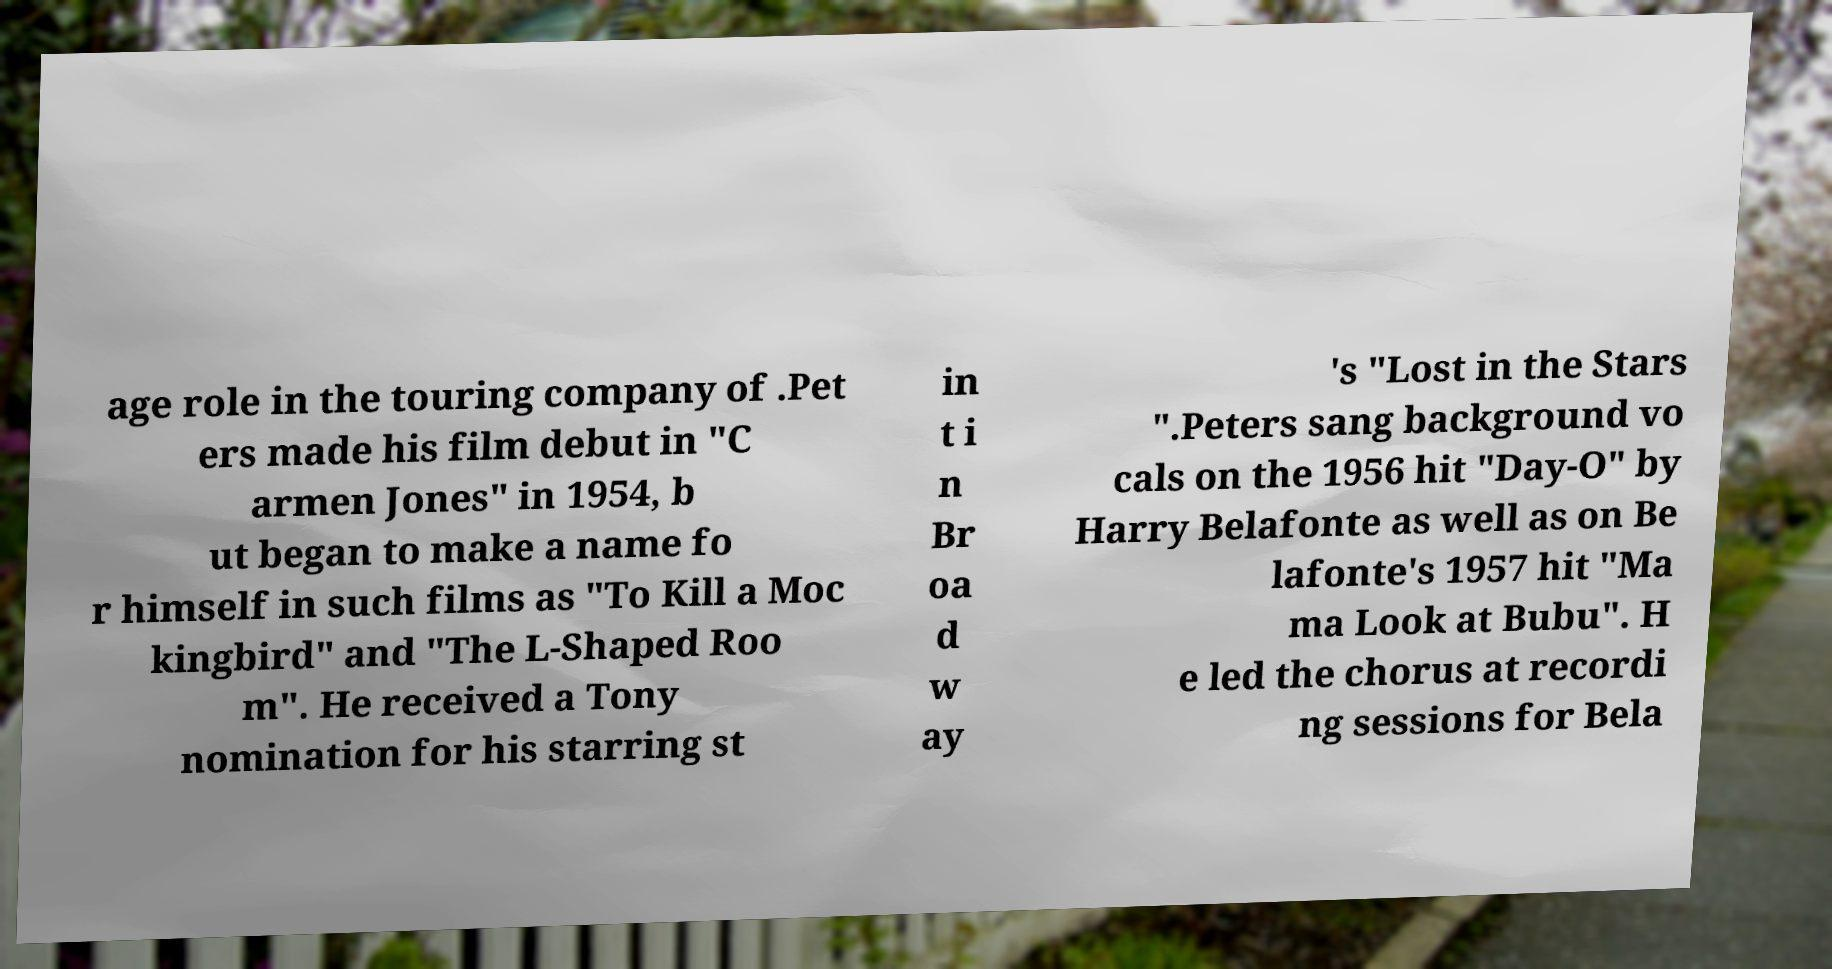For documentation purposes, I need the text within this image transcribed. Could you provide that? age role in the touring company of .Pet ers made his film debut in "C armen Jones" in 1954, b ut began to make a name fo r himself in such films as "To Kill a Moc kingbird" and "The L-Shaped Roo m". He received a Tony nomination for his starring st in t i n Br oa d w ay 's "Lost in the Stars ".Peters sang background vo cals on the 1956 hit "Day-O" by Harry Belafonte as well as on Be lafonte's 1957 hit "Ma ma Look at Bubu". H e led the chorus at recordi ng sessions for Bela 